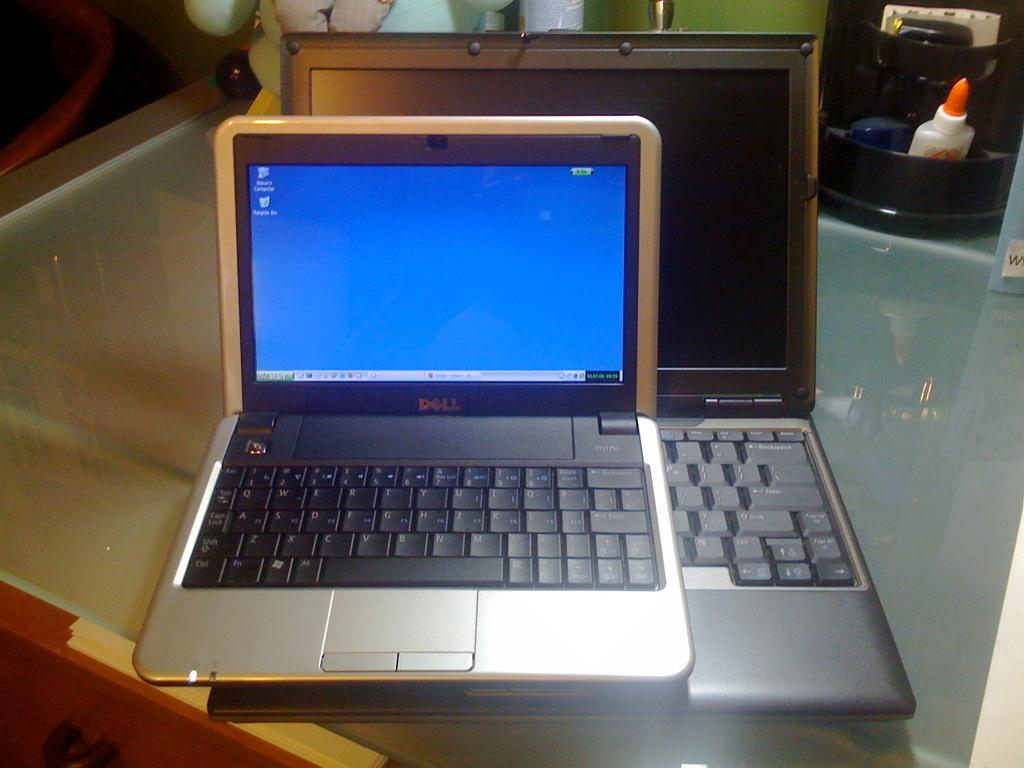What electronic devices are on the table in the image? There are laptops on a table in the image. Can you describe any other objects or items visible in the image? There are additional items visible in the background of the image, but their specific details are not provided. What type of underwear is hanging from the street lamp in the image? There is no underwear or street lamp present in the image; it only features laptops on a table and additional items in the background. 